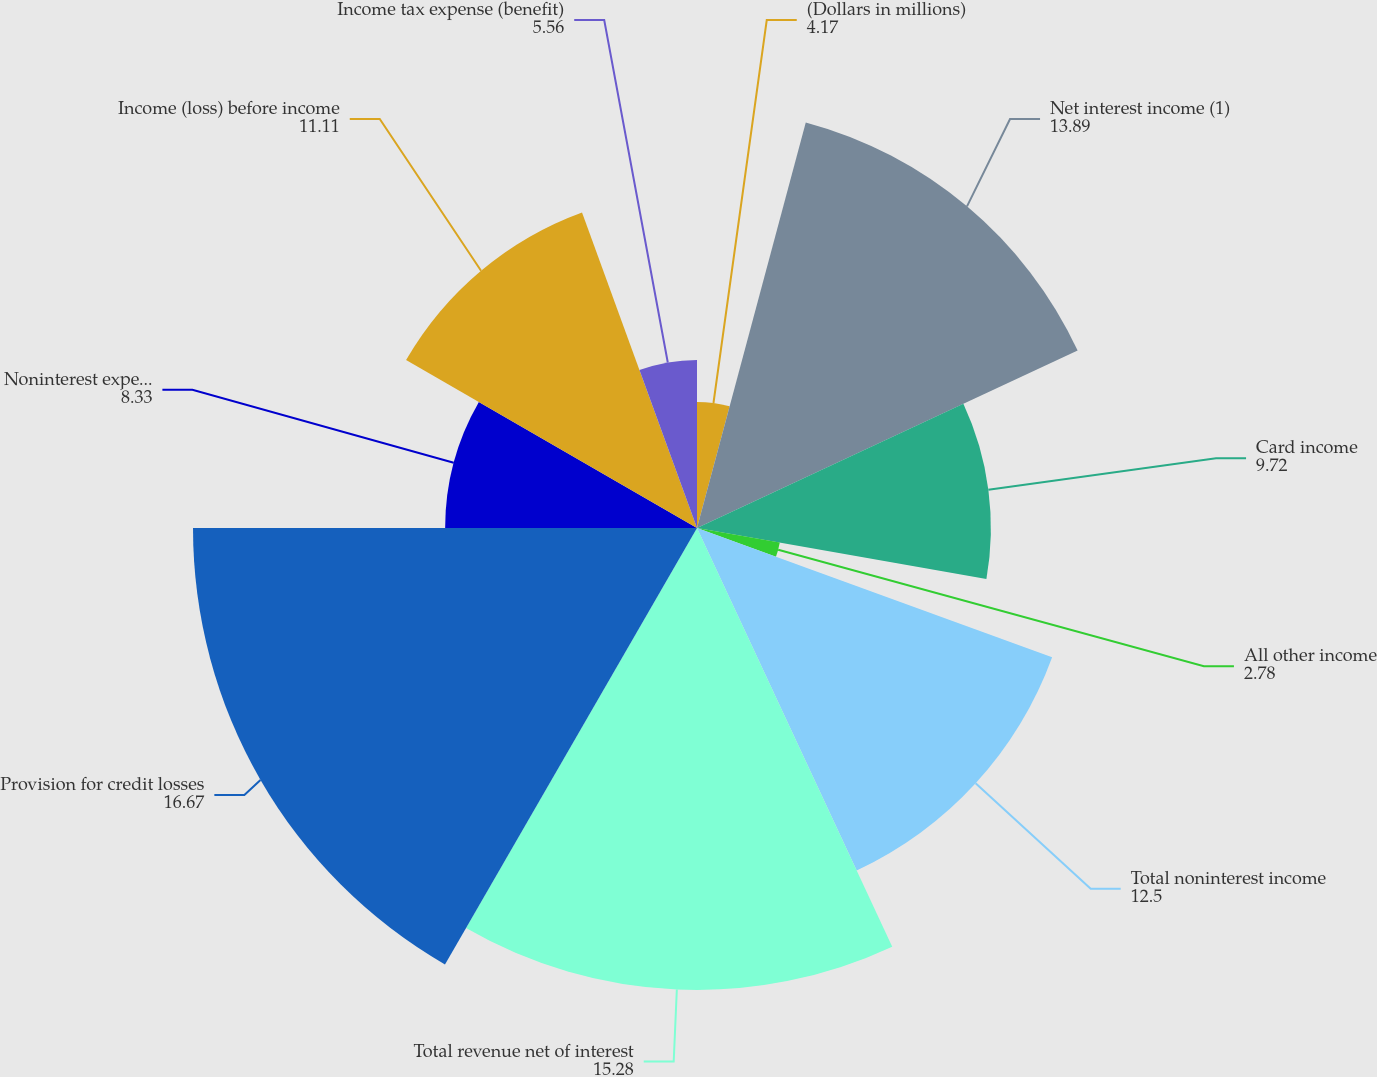<chart> <loc_0><loc_0><loc_500><loc_500><pie_chart><fcel>(Dollars in millions)<fcel>Net interest income (1)<fcel>Card income<fcel>All other income<fcel>Total noninterest income<fcel>Total revenue net of interest<fcel>Provision for credit losses<fcel>Noninterest expense<fcel>Income (loss) before income<fcel>Income tax expense (benefit)<nl><fcel>4.17%<fcel>13.89%<fcel>9.72%<fcel>2.78%<fcel>12.5%<fcel>15.28%<fcel>16.67%<fcel>8.33%<fcel>11.11%<fcel>5.56%<nl></chart> 